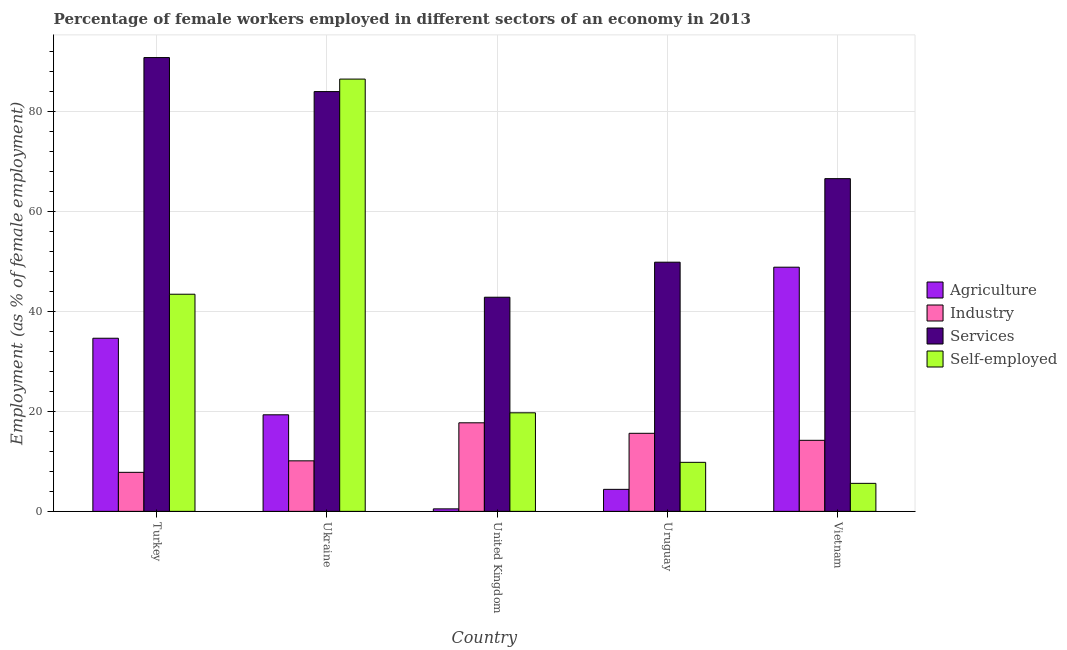Are the number of bars per tick equal to the number of legend labels?
Offer a very short reply. Yes. Are the number of bars on each tick of the X-axis equal?
Your response must be concise. Yes. How many bars are there on the 4th tick from the left?
Your answer should be compact. 4. What is the label of the 5th group of bars from the left?
Offer a very short reply. Vietnam. In how many cases, is the number of bars for a given country not equal to the number of legend labels?
Keep it short and to the point. 0. What is the percentage of self employed female workers in Turkey?
Ensure brevity in your answer.  43.4. Across all countries, what is the maximum percentage of female workers in agriculture?
Ensure brevity in your answer.  48.8. Across all countries, what is the minimum percentage of female workers in industry?
Offer a very short reply. 7.8. In which country was the percentage of female workers in services maximum?
Your response must be concise. Turkey. In which country was the percentage of female workers in industry minimum?
Ensure brevity in your answer.  Turkey. What is the total percentage of self employed female workers in the graph?
Your answer should be very brief. 164.9. What is the difference between the percentage of self employed female workers in Ukraine and that in Uruguay?
Your response must be concise. 76.6. What is the difference between the percentage of female workers in services in Turkey and the percentage of self employed female workers in Uruguay?
Give a very brief answer. 80.9. What is the average percentage of female workers in agriculture per country?
Make the answer very short. 21.52. What is the difference between the percentage of female workers in services and percentage of female workers in industry in Vietnam?
Offer a terse response. 52.3. In how many countries, is the percentage of self employed female workers greater than 88 %?
Keep it short and to the point. 0. What is the ratio of the percentage of female workers in industry in United Kingdom to that in Uruguay?
Offer a terse response. 1.13. Is the difference between the percentage of female workers in industry in Turkey and Vietnam greater than the difference between the percentage of female workers in services in Turkey and Vietnam?
Provide a succinct answer. No. What is the difference between the highest and the second highest percentage of self employed female workers?
Offer a very short reply. 43. What is the difference between the highest and the lowest percentage of female workers in agriculture?
Give a very brief answer. 48.3. What does the 2nd bar from the left in Uruguay represents?
Ensure brevity in your answer.  Industry. What does the 2nd bar from the right in Ukraine represents?
Keep it short and to the point. Services. Are the values on the major ticks of Y-axis written in scientific E-notation?
Ensure brevity in your answer.  No. Where does the legend appear in the graph?
Keep it short and to the point. Center right. How many legend labels are there?
Your response must be concise. 4. How are the legend labels stacked?
Give a very brief answer. Vertical. What is the title of the graph?
Keep it short and to the point. Percentage of female workers employed in different sectors of an economy in 2013. What is the label or title of the Y-axis?
Give a very brief answer. Employment (as % of female employment). What is the Employment (as % of female employment) in Agriculture in Turkey?
Ensure brevity in your answer.  34.6. What is the Employment (as % of female employment) in Industry in Turkey?
Give a very brief answer. 7.8. What is the Employment (as % of female employment) in Services in Turkey?
Your answer should be very brief. 90.7. What is the Employment (as % of female employment) of Self-employed in Turkey?
Make the answer very short. 43.4. What is the Employment (as % of female employment) of Agriculture in Ukraine?
Your answer should be compact. 19.3. What is the Employment (as % of female employment) in Industry in Ukraine?
Keep it short and to the point. 10.1. What is the Employment (as % of female employment) of Services in Ukraine?
Your answer should be very brief. 83.9. What is the Employment (as % of female employment) in Self-employed in Ukraine?
Provide a short and direct response. 86.4. What is the Employment (as % of female employment) of Industry in United Kingdom?
Provide a succinct answer. 17.7. What is the Employment (as % of female employment) of Services in United Kingdom?
Provide a short and direct response. 42.8. What is the Employment (as % of female employment) in Self-employed in United Kingdom?
Your answer should be very brief. 19.7. What is the Employment (as % of female employment) in Agriculture in Uruguay?
Offer a terse response. 4.4. What is the Employment (as % of female employment) of Industry in Uruguay?
Your response must be concise. 15.6. What is the Employment (as % of female employment) in Services in Uruguay?
Offer a very short reply. 49.8. What is the Employment (as % of female employment) of Self-employed in Uruguay?
Offer a terse response. 9.8. What is the Employment (as % of female employment) of Agriculture in Vietnam?
Provide a succinct answer. 48.8. What is the Employment (as % of female employment) in Industry in Vietnam?
Your answer should be very brief. 14.2. What is the Employment (as % of female employment) of Services in Vietnam?
Give a very brief answer. 66.5. What is the Employment (as % of female employment) in Self-employed in Vietnam?
Your answer should be very brief. 5.6. Across all countries, what is the maximum Employment (as % of female employment) of Agriculture?
Offer a very short reply. 48.8. Across all countries, what is the maximum Employment (as % of female employment) of Industry?
Offer a terse response. 17.7. Across all countries, what is the maximum Employment (as % of female employment) of Services?
Keep it short and to the point. 90.7. Across all countries, what is the maximum Employment (as % of female employment) of Self-employed?
Offer a very short reply. 86.4. Across all countries, what is the minimum Employment (as % of female employment) of Industry?
Provide a succinct answer. 7.8. Across all countries, what is the minimum Employment (as % of female employment) of Services?
Your answer should be compact. 42.8. Across all countries, what is the minimum Employment (as % of female employment) of Self-employed?
Offer a terse response. 5.6. What is the total Employment (as % of female employment) of Agriculture in the graph?
Make the answer very short. 107.6. What is the total Employment (as % of female employment) in Industry in the graph?
Give a very brief answer. 65.4. What is the total Employment (as % of female employment) of Services in the graph?
Provide a short and direct response. 333.7. What is the total Employment (as % of female employment) of Self-employed in the graph?
Your answer should be compact. 164.9. What is the difference between the Employment (as % of female employment) in Agriculture in Turkey and that in Ukraine?
Offer a very short reply. 15.3. What is the difference between the Employment (as % of female employment) of Industry in Turkey and that in Ukraine?
Keep it short and to the point. -2.3. What is the difference between the Employment (as % of female employment) in Self-employed in Turkey and that in Ukraine?
Ensure brevity in your answer.  -43. What is the difference between the Employment (as % of female employment) of Agriculture in Turkey and that in United Kingdom?
Provide a succinct answer. 34.1. What is the difference between the Employment (as % of female employment) in Services in Turkey and that in United Kingdom?
Your answer should be compact. 47.9. What is the difference between the Employment (as % of female employment) in Self-employed in Turkey and that in United Kingdom?
Your answer should be compact. 23.7. What is the difference between the Employment (as % of female employment) of Agriculture in Turkey and that in Uruguay?
Your response must be concise. 30.2. What is the difference between the Employment (as % of female employment) of Services in Turkey and that in Uruguay?
Provide a short and direct response. 40.9. What is the difference between the Employment (as % of female employment) in Self-employed in Turkey and that in Uruguay?
Your response must be concise. 33.6. What is the difference between the Employment (as % of female employment) of Services in Turkey and that in Vietnam?
Offer a very short reply. 24.2. What is the difference between the Employment (as % of female employment) of Self-employed in Turkey and that in Vietnam?
Keep it short and to the point. 37.8. What is the difference between the Employment (as % of female employment) of Agriculture in Ukraine and that in United Kingdom?
Keep it short and to the point. 18.8. What is the difference between the Employment (as % of female employment) in Industry in Ukraine and that in United Kingdom?
Ensure brevity in your answer.  -7.6. What is the difference between the Employment (as % of female employment) of Services in Ukraine and that in United Kingdom?
Offer a terse response. 41.1. What is the difference between the Employment (as % of female employment) in Self-employed in Ukraine and that in United Kingdom?
Keep it short and to the point. 66.7. What is the difference between the Employment (as % of female employment) of Agriculture in Ukraine and that in Uruguay?
Offer a very short reply. 14.9. What is the difference between the Employment (as % of female employment) of Industry in Ukraine and that in Uruguay?
Your answer should be very brief. -5.5. What is the difference between the Employment (as % of female employment) in Services in Ukraine and that in Uruguay?
Your answer should be very brief. 34.1. What is the difference between the Employment (as % of female employment) of Self-employed in Ukraine and that in Uruguay?
Offer a terse response. 76.6. What is the difference between the Employment (as % of female employment) of Agriculture in Ukraine and that in Vietnam?
Offer a very short reply. -29.5. What is the difference between the Employment (as % of female employment) of Industry in Ukraine and that in Vietnam?
Give a very brief answer. -4.1. What is the difference between the Employment (as % of female employment) of Services in Ukraine and that in Vietnam?
Your answer should be very brief. 17.4. What is the difference between the Employment (as % of female employment) in Self-employed in Ukraine and that in Vietnam?
Offer a very short reply. 80.8. What is the difference between the Employment (as % of female employment) of Self-employed in United Kingdom and that in Uruguay?
Keep it short and to the point. 9.9. What is the difference between the Employment (as % of female employment) in Agriculture in United Kingdom and that in Vietnam?
Your response must be concise. -48.3. What is the difference between the Employment (as % of female employment) of Services in United Kingdom and that in Vietnam?
Offer a terse response. -23.7. What is the difference between the Employment (as % of female employment) of Agriculture in Uruguay and that in Vietnam?
Keep it short and to the point. -44.4. What is the difference between the Employment (as % of female employment) in Services in Uruguay and that in Vietnam?
Your answer should be compact. -16.7. What is the difference between the Employment (as % of female employment) of Self-employed in Uruguay and that in Vietnam?
Ensure brevity in your answer.  4.2. What is the difference between the Employment (as % of female employment) of Agriculture in Turkey and the Employment (as % of female employment) of Services in Ukraine?
Your answer should be very brief. -49.3. What is the difference between the Employment (as % of female employment) of Agriculture in Turkey and the Employment (as % of female employment) of Self-employed in Ukraine?
Offer a terse response. -51.8. What is the difference between the Employment (as % of female employment) in Industry in Turkey and the Employment (as % of female employment) in Services in Ukraine?
Your answer should be very brief. -76.1. What is the difference between the Employment (as % of female employment) of Industry in Turkey and the Employment (as % of female employment) of Self-employed in Ukraine?
Keep it short and to the point. -78.6. What is the difference between the Employment (as % of female employment) in Agriculture in Turkey and the Employment (as % of female employment) in Industry in United Kingdom?
Your response must be concise. 16.9. What is the difference between the Employment (as % of female employment) of Agriculture in Turkey and the Employment (as % of female employment) of Services in United Kingdom?
Ensure brevity in your answer.  -8.2. What is the difference between the Employment (as % of female employment) in Industry in Turkey and the Employment (as % of female employment) in Services in United Kingdom?
Your answer should be very brief. -35. What is the difference between the Employment (as % of female employment) in Services in Turkey and the Employment (as % of female employment) in Self-employed in United Kingdom?
Ensure brevity in your answer.  71. What is the difference between the Employment (as % of female employment) in Agriculture in Turkey and the Employment (as % of female employment) in Industry in Uruguay?
Provide a succinct answer. 19. What is the difference between the Employment (as % of female employment) in Agriculture in Turkey and the Employment (as % of female employment) in Services in Uruguay?
Keep it short and to the point. -15.2. What is the difference between the Employment (as % of female employment) of Agriculture in Turkey and the Employment (as % of female employment) of Self-employed in Uruguay?
Make the answer very short. 24.8. What is the difference between the Employment (as % of female employment) of Industry in Turkey and the Employment (as % of female employment) of Services in Uruguay?
Your answer should be very brief. -42. What is the difference between the Employment (as % of female employment) of Services in Turkey and the Employment (as % of female employment) of Self-employed in Uruguay?
Provide a succinct answer. 80.9. What is the difference between the Employment (as % of female employment) of Agriculture in Turkey and the Employment (as % of female employment) of Industry in Vietnam?
Make the answer very short. 20.4. What is the difference between the Employment (as % of female employment) of Agriculture in Turkey and the Employment (as % of female employment) of Services in Vietnam?
Provide a short and direct response. -31.9. What is the difference between the Employment (as % of female employment) of Industry in Turkey and the Employment (as % of female employment) of Services in Vietnam?
Your response must be concise. -58.7. What is the difference between the Employment (as % of female employment) of Services in Turkey and the Employment (as % of female employment) of Self-employed in Vietnam?
Your response must be concise. 85.1. What is the difference between the Employment (as % of female employment) in Agriculture in Ukraine and the Employment (as % of female employment) in Services in United Kingdom?
Your response must be concise. -23.5. What is the difference between the Employment (as % of female employment) of Industry in Ukraine and the Employment (as % of female employment) of Services in United Kingdom?
Make the answer very short. -32.7. What is the difference between the Employment (as % of female employment) in Industry in Ukraine and the Employment (as % of female employment) in Self-employed in United Kingdom?
Offer a very short reply. -9.6. What is the difference between the Employment (as % of female employment) of Services in Ukraine and the Employment (as % of female employment) of Self-employed in United Kingdom?
Keep it short and to the point. 64.2. What is the difference between the Employment (as % of female employment) of Agriculture in Ukraine and the Employment (as % of female employment) of Industry in Uruguay?
Offer a terse response. 3.7. What is the difference between the Employment (as % of female employment) of Agriculture in Ukraine and the Employment (as % of female employment) of Services in Uruguay?
Keep it short and to the point. -30.5. What is the difference between the Employment (as % of female employment) of Agriculture in Ukraine and the Employment (as % of female employment) of Self-employed in Uruguay?
Keep it short and to the point. 9.5. What is the difference between the Employment (as % of female employment) of Industry in Ukraine and the Employment (as % of female employment) of Services in Uruguay?
Provide a succinct answer. -39.7. What is the difference between the Employment (as % of female employment) in Services in Ukraine and the Employment (as % of female employment) in Self-employed in Uruguay?
Provide a succinct answer. 74.1. What is the difference between the Employment (as % of female employment) in Agriculture in Ukraine and the Employment (as % of female employment) in Industry in Vietnam?
Offer a very short reply. 5.1. What is the difference between the Employment (as % of female employment) of Agriculture in Ukraine and the Employment (as % of female employment) of Services in Vietnam?
Make the answer very short. -47.2. What is the difference between the Employment (as % of female employment) in Agriculture in Ukraine and the Employment (as % of female employment) in Self-employed in Vietnam?
Your answer should be compact. 13.7. What is the difference between the Employment (as % of female employment) of Industry in Ukraine and the Employment (as % of female employment) of Services in Vietnam?
Keep it short and to the point. -56.4. What is the difference between the Employment (as % of female employment) of Industry in Ukraine and the Employment (as % of female employment) of Self-employed in Vietnam?
Provide a short and direct response. 4.5. What is the difference between the Employment (as % of female employment) of Services in Ukraine and the Employment (as % of female employment) of Self-employed in Vietnam?
Your response must be concise. 78.3. What is the difference between the Employment (as % of female employment) in Agriculture in United Kingdom and the Employment (as % of female employment) in Industry in Uruguay?
Your answer should be very brief. -15.1. What is the difference between the Employment (as % of female employment) of Agriculture in United Kingdom and the Employment (as % of female employment) of Services in Uruguay?
Make the answer very short. -49.3. What is the difference between the Employment (as % of female employment) in Industry in United Kingdom and the Employment (as % of female employment) in Services in Uruguay?
Offer a very short reply. -32.1. What is the difference between the Employment (as % of female employment) in Industry in United Kingdom and the Employment (as % of female employment) in Self-employed in Uruguay?
Your answer should be compact. 7.9. What is the difference between the Employment (as % of female employment) in Services in United Kingdom and the Employment (as % of female employment) in Self-employed in Uruguay?
Offer a terse response. 33. What is the difference between the Employment (as % of female employment) of Agriculture in United Kingdom and the Employment (as % of female employment) of Industry in Vietnam?
Offer a terse response. -13.7. What is the difference between the Employment (as % of female employment) of Agriculture in United Kingdom and the Employment (as % of female employment) of Services in Vietnam?
Provide a succinct answer. -66. What is the difference between the Employment (as % of female employment) of Industry in United Kingdom and the Employment (as % of female employment) of Services in Vietnam?
Offer a terse response. -48.8. What is the difference between the Employment (as % of female employment) in Industry in United Kingdom and the Employment (as % of female employment) in Self-employed in Vietnam?
Keep it short and to the point. 12.1. What is the difference between the Employment (as % of female employment) of Services in United Kingdom and the Employment (as % of female employment) of Self-employed in Vietnam?
Your answer should be very brief. 37.2. What is the difference between the Employment (as % of female employment) of Agriculture in Uruguay and the Employment (as % of female employment) of Services in Vietnam?
Your response must be concise. -62.1. What is the difference between the Employment (as % of female employment) in Industry in Uruguay and the Employment (as % of female employment) in Services in Vietnam?
Make the answer very short. -50.9. What is the difference between the Employment (as % of female employment) of Services in Uruguay and the Employment (as % of female employment) of Self-employed in Vietnam?
Ensure brevity in your answer.  44.2. What is the average Employment (as % of female employment) of Agriculture per country?
Give a very brief answer. 21.52. What is the average Employment (as % of female employment) in Industry per country?
Provide a short and direct response. 13.08. What is the average Employment (as % of female employment) in Services per country?
Offer a terse response. 66.74. What is the average Employment (as % of female employment) of Self-employed per country?
Offer a terse response. 32.98. What is the difference between the Employment (as % of female employment) in Agriculture and Employment (as % of female employment) in Industry in Turkey?
Make the answer very short. 26.8. What is the difference between the Employment (as % of female employment) of Agriculture and Employment (as % of female employment) of Services in Turkey?
Give a very brief answer. -56.1. What is the difference between the Employment (as % of female employment) in Agriculture and Employment (as % of female employment) in Self-employed in Turkey?
Offer a very short reply. -8.8. What is the difference between the Employment (as % of female employment) of Industry and Employment (as % of female employment) of Services in Turkey?
Give a very brief answer. -82.9. What is the difference between the Employment (as % of female employment) of Industry and Employment (as % of female employment) of Self-employed in Turkey?
Your answer should be very brief. -35.6. What is the difference between the Employment (as % of female employment) of Services and Employment (as % of female employment) of Self-employed in Turkey?
Give a very brief answer. 47.3. What is the difference between the Employment (as % of female employment) in Agriculture and Employment (as % of female employment) in Services in Ukraine?
Your response must be concise. -64.6. What is the difference between the Employment (as % of female employment) of Agriculture and Employment (as % of female employment) of Self-employed in Ukraine?
Keep it short and to the point. -67.1. What is the difference between the Employment (as % of female employment) in Industry and Employment (as % of female employment) in Services in Ukraine?
Provide a succinct answer. -73.8. What is the difference between the Employment (as % of female employment) of Industry and Employment (as % of female employment) of Self-employed in Ukraine?
Your answer should be very brief. -76.3. What is the difference between the Employment (as % of female employment) in Services and Employment (as % of female employment) in Self-employed in Ukraine?
Provide a short and direct response. -2.5. What is the difference between the Employment (as % of female employment) of Agriculture and Employment (as % of female employment) of Industry in United Kingdom?
Provide a short and direct response. -17.2. What is the difference between the Employment (as % of female employment) of Agriculture and Employment (as % of female employment) of Services in United Kingdom?
Offer a terse response. -42.3. What is the difference between the Employment (as % of female employment) of Agriculture and Employment (as % of female employment) of Self-employed in United Kingdom?
Your answer should be very brief. -19.2. What is the difference between the Employment (as % of female employment) in Industry and Employment (as % of female employment) in Services in United Kingdom?
Your answer should be very brief. -25.1. What is the difference between the Employment (as % of female employment) in Services and Employment (as % of female employment) in Self-employed in United Kingdom?
Provide a succinct answer. 23.1. What is the difference between the Employment (as % of female employment) in Agriculture and Employment (as % of female employment) in Industry in Uruguay?
Make the answer very short. -11.2. What is the difference between the Employment (as % of female employment) of Agriculture and Employment (as % of female employment) of Services in Uruguay?
Keep it short and to the point. -45.4. What is the difference between the Employment (as % of female employment) in Agriculture and Employment (as % of female employment) in Self-employed in Uruguay?
Provide a succinct answer. -5.4. What is the difference between the Employment (as % of female employment) in Industry and Employment (as % of female employment) in Services in Uruguay?
Your answer should be very brief. -34.2. What is the difference between the Employment (as % of female employment) of Services and Employment (as % of female employment) of Self-employed in Uruguay?
Your answer should be very brief. 40. What is the difference between the Employment (as % of female employment) in Agriculture and Employment (as % of female employment) in Industry in Vietnam?
Ensure brevity in your answer.  34.6. What is the difference between the Employment (as % of female employment) in Agriculture and Employment (as % of female employment) in Services in Vietnam?
Your answer should be very brief. -17.7. What is the difference between the Employment (as % of female employment) of Agriculture and Employment (as % of female employment) of Self-employed in Vietnam?
Provide a succinct answer. 43.2. What is the difference between the Employment (as % of female employment) of Industry and Employment (as % of female employment) of Services in Vietnam?
Keep it short and to the point. -52.3. What is the difference between the Employment (as % of female employment) of Industry and Employment (as % of female employment) of Self-employed in Vietnam?
Your response must be concise. 8.6. What is the difference between the Employment (as % of female employment) of Services and Employment (as % of female employment) of Self-employed in Vietnam?
Make the answer very short. 60.9. What is the ratio of the Employment (as % of female employment) in Agriculture in Turkey to that in Ukraine?
Your response must be concise. 1.79. What is the ratio of the Employment (as % of female employment) of Industry in Turkey to that in Ukraine?
Provide a succinct answer. 0.77. What is the ratio of the Employment (as % of female employment) in Services in Turkey to that in Ukraine?
Ensure brevity in your answer.  1.08. What is the ratio of the Employment (as % of female employment) in Self-employed in Turkey to that in Ukraine?
Offer a terse response. 0.5. What is the ratio of the Employment (as % of female employment) of Agriculture in Turkey to that in United Kingdom?
Make the answer very short. 69.2. What is the ratio of the Employment (as % of female employment) in Industry in Turkey to that in United Kingdom?
Ensure brevity in your answer.  0.44. What is the ratio of the Employment (as % of female employment) of Services in Turkey to that in United Kingdom?
Provide a short and direct response. 2.12. What is the ratio of the Employment (as % of female employment) of Self-employed in Turkey to that in United Kingdom?
Offer a terse response. 2.2. What is the ratio of the Employment (as % of female employment) of Agriculture in Turkey to that in Uruguay?
Give a very brief answer. 7.86. What is the ratio of the Employment (as % of female employment) in Services in Turkey to that in Uruguay?
Keep it short and to the point. 1.82. What is the ratio of the Employment (as % of female employment) in Self-employed in Turkey to that in Uruguay?
Offer a very short reply. 4.43. What is the ratio of the Employment (as % of female employment) of Agriculture in Turkey to that in Vietnam?
Give a very brief answer. 0.71. What is the ratio of the Employment (as % of female employment) in Industry in Turkey to that in Vietnam?
Your answer should be very brief. 0.55. What is the ratio of the Employment (as % of female employment) of Services in Turkey to that in Vietnam?
Offer a very short reply. 1.36. What is the ratio of the Employment (as % of female employment) of Self-employed in Turkey to that in Vietnam?
Your answer should be compact. 7.75. What is the ratio of the Employment (as % of female employment) in Agriculture in Ukraine to that in United Kingdom?
Your answer should be compact. 38.6. What is the ratio of the Employment (as % of female employment) of Industry in Ukraine to that in United Kingdom?
Keep it short and to the point. 0.57. What is the ratio of the Employment (as % of female employment) of Services in Ukraine to that in United Kingdom?
Provide a succinct answer. 1.96. What is the ratio of the Employment (as % of female employment) in Self-employed in Ukraine to that in United Kingdom?
Keep it short and to the point. 4.39. What is the ratio of the Employment (as % of female employment) in Agriculture in Ukraine to that in Uruguay?
Make the answer very short. 4.39. What is the ratio of the Employment (as % of female employment) in Industry in Ukraine to that in Uruguay?
Offer a very short reply. 0.65. What is the ratio of the Employment (as % of female employment) in Services in Ukraine to that in Uruguay?
Make the answer very short. 1.68. What is the ratio of the Employment (as % of female employment) in Self-employed in Ukraine to that in Uruguay?
Your response must be concise. 8.82. What is the ratio of the Employment (as % of female employment) of Agriculture in Ukraine to that in Vietnam?
Provide a succinct answer. 0.4. What is the ratio of the Employment (as % of female employment) of Industry in Ukraine to that in Vietnam?
Offer a terse response. 0.71. What is the ratio of the Employment (as % of female employment) of Services in Ukraine to that in Vietnam?
Your answer should be compact. 1.26. What is the ratio of the Employment (as % of female employment) of Self-employed in Ukraine to that in Vietnam?
Your answer should be very brief. 15.43. What is the ratio of the Employment (as % of female employment) in Agriculture in United Kingdom to that in Uruguay?
Keep it short and to the point. 0.11. What is the ratio of the Employment (as % of female employment) of Industry in United Kingdom to that in Uruguay?
Offer a very short reply. 1.13. What is the ratio of the Employment (as % of female employment) in Services in United Kingdom to that in Uruguay?
Your answer should be compact. 0.86. What is the ratio of the Employment (as % of female employment) in Self-employed in United Kingdom to that in Uruguay?
Offer a terse response. 2.01. What is the ratio of the Employment (as % of female employment) of Agriculture in United Kingdom to that in Vietnam?
Give a very brief answer. 0.01. What is the ratio of the Employment (as % of female employment) of Industry in United Kingdom to that in Vietnam?
Your answer should be very brief. 1.25. What is the ratio of the Employment (as % of female employment) of Services in United Kingdom to that in Vietnam?
Keep it short and to the point. 0.64. What is the ratio of the Employment (as % of female employment) in Self-employed in United Kingdom to that in Vietnam?
Your response must be concise. 3.52. What is the ratio of the Employment (as % of female employment) of Agriculture in Uruguay to that in Vietnam?
Ensure brevity in your answer.  0.09. What is the ratio of the Employment (as % of female employment) of Industry in Uruguay to that in Vietnam?
Keep it short and to the point. 1.1. What is the ratio of the Employment (as % of female employment) in Services in Uruguay to that in Vietnam?
Keep it short and to the point. 0.75. What is the ratio of the Employment (as % of female employment) in Self-employed in Uruguay to that in Vietnam?
Your response must be concise. 1.75. What is the difference between the highest and the second highest Employment (as % of female employment) of Agriculture?
Provide a succinct answer. 14.2. What is the difference between the highest and the second highest Employment (as % of female employment) of Industry?
Provide a short and direct response. 2.1. What is the difference between the highest and the lowest Employment (as % of female employment) of Agriculture?
Make the answer very short. 48.3. What is the difference between the highest and the lowest Employment (as % of female employment) in Services?
Keep it short and to the point. 47.9. What is the difference between the highest and the lowest Employment (as % of female employment) in Self-employed?
Provide a succinct answer. 80.8. 